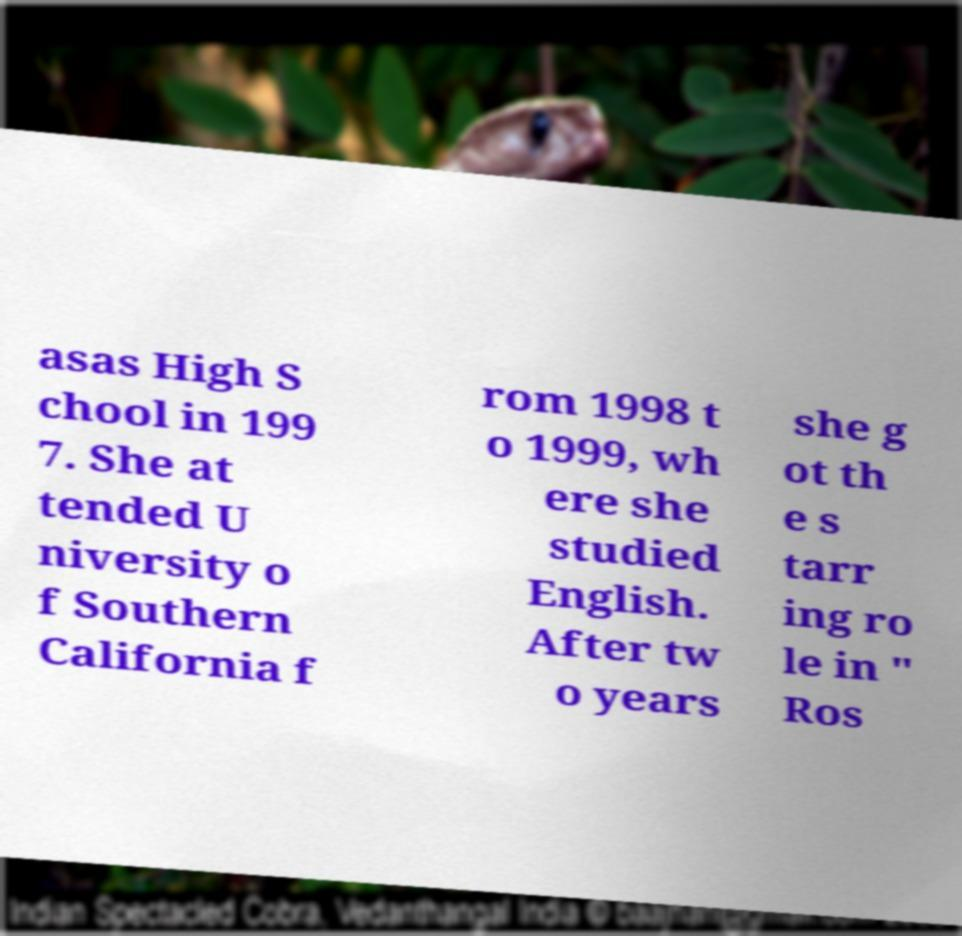Please read and relay the text visible in this image. What does it say? asas High S chool in 199 7. She at tended U niversity o f Southern California f rom 1998 t o 1999, wh ere she studied English. After tw o years she g ot th e s tarr ing ro le in " Ros 